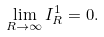Convert formula to latex. <formula><loc_0><loc_0><loc_500><loc_500>\lim _ { R \rightarrow \infty } I _ { R } ^ { 1 } = 0 .</formula> 